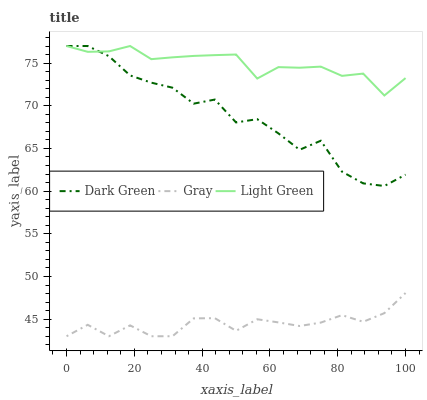Does Gray have the minimum area under the curve?
Answer yes or no. Yes. Does Light Green have the maximum area under the curve?
Answer yes or no. Yes. Does Dark Green have the minimum area under the curve?
Answer yes or no. No. Does Dark Green have the maximum area under the curve?
Answer yes or no. No. Is Light Green the smoothest?
Answer yes or no. Yes. Is Dark Green the roughest?
Answer yes or no. Yes. Is Dark Green the smoothest?
Answer yes or no. No. Is Light Green the roughest?
Answer yes or no. No. Does Dark Green have the lowest value?
Answer yes or no. No. Is Gray less than Dark Green?
Answer yes or no. Yes. Is Light Green greater than Gray?
Answer yes or no. Yes. Does Gray intersect Dark Green?
Answer yes or no. No. 